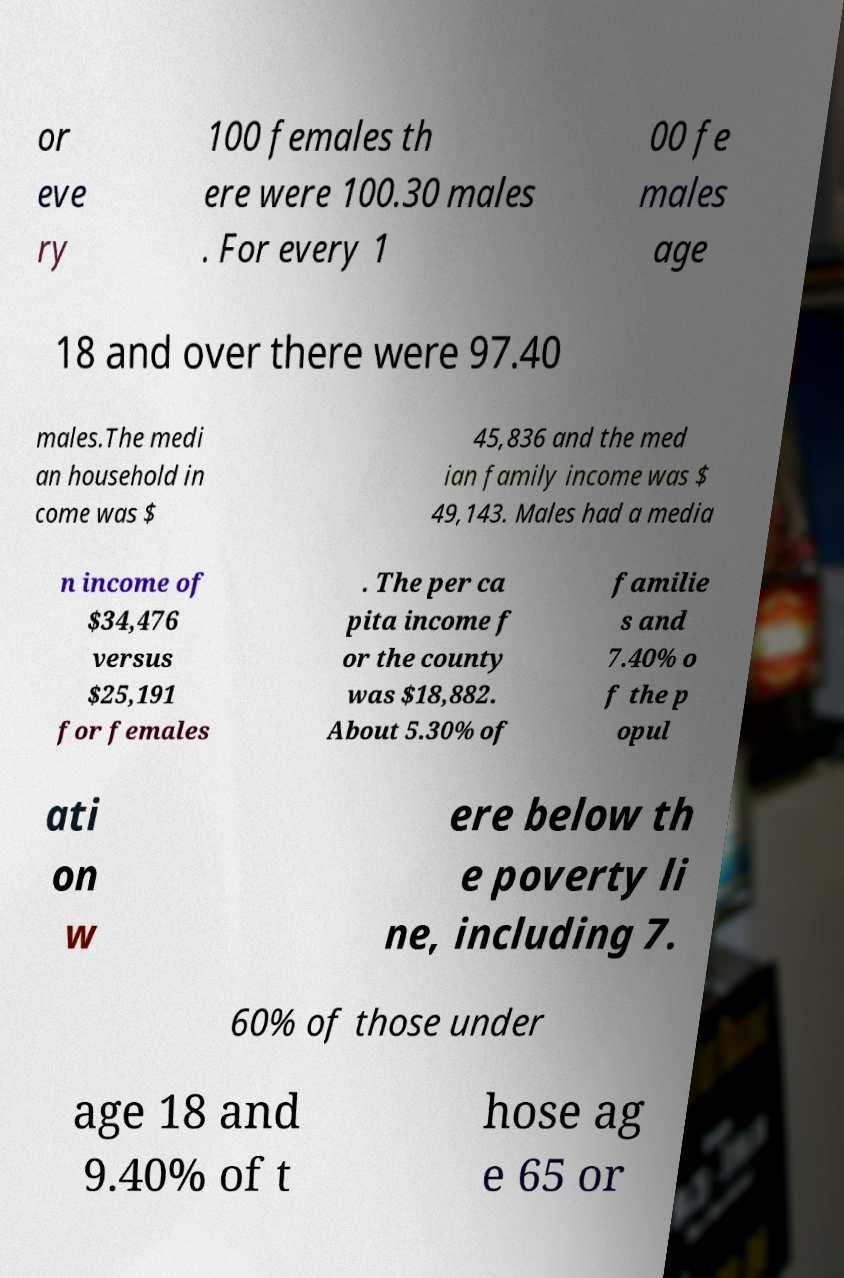Could you assist in decoding the text presented in this image and type it out clearly? or eve ry 100 females th ere were 100.30 males . For every 1 00 fe males age 18 and over there were 97.40 males.The medi an household in come was $ 45,836 and the med ian family income was $ 49,143. Males had a media n income of $34,476 versus $25,191 for females . The per ca pita income f or the county was $18,882. About 5.30% of familie s and 7.40% o f the p opul ati on w ere below th e poverty li ne, including 7. 60% of those under age 18 and 9.40% of t hose ag e 65 or 